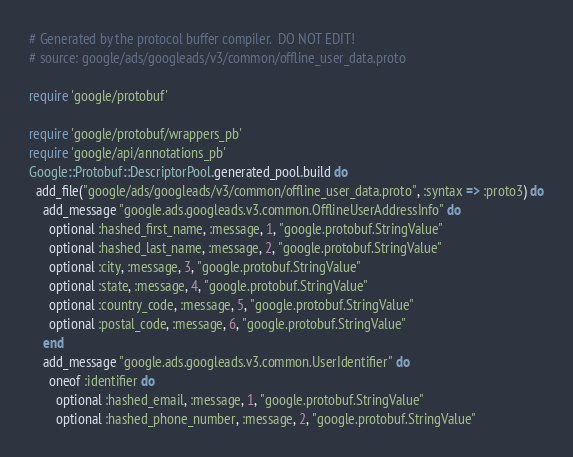Convert code to text. <code><loc_0><loc_0><loc_500><loc_500><_Ruby_># Generated by the protocol buffer compiler.  DO NOT EDIT!
# source: google/ads/googleads/v3/common/offline_user_data.proto

require 'google/protobuf'

require 'google/protobuf/wrappers_pb'
require 'google/api/annotations_pb'
Google::Protobuf::DescriptorPool.generated_pool.build do
  add_file("google/ads/googleads/v3/common/offline_user_data.proto", :syntax => :proto3) do
    add_message "google.ads.googleads.v3.common.OfflineUserAddressInfo" do
      optional :hashed_first_name, :message, 1, "google.protobuf.StringValue"
      optional :hashed_last_name, :message, 2, "google.protobuf.StringValue"
      optional :city, :message, 3, "google.protobuf.StringValue"
      optional :state, :message, 4, "google.protobuf.StringValue"
      optional :country_code, :message, 5, "google.protobuf.StringValue"
      optional :postal_code, :message, 6, "google.protobuf.StringValue"
    end
    add_message "google.ads.googleads.v3.common.UserIdentifier" do
      oneof :identifier do
        optional :hashed_email, :message, 1, "google.protobuf.StringValue"
        optional :hashed_phone_number, :message, 2, "google.protobuf.StringValue"</code> 